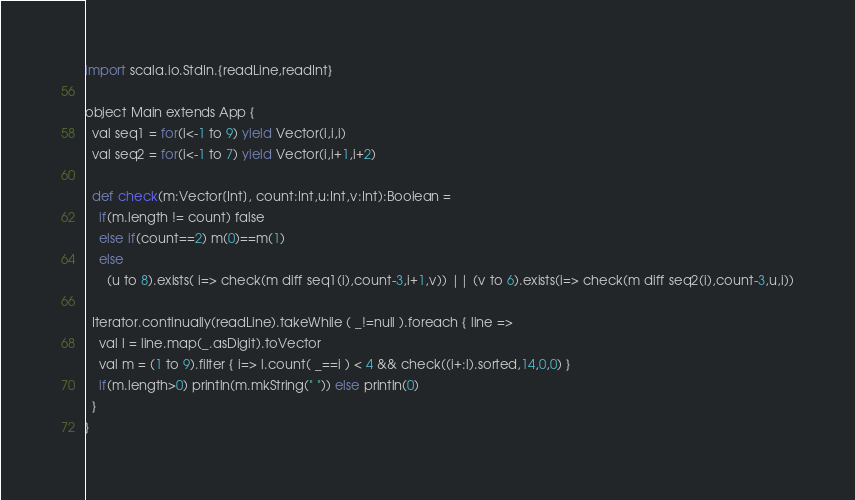Convert code to text. <code><loc_0><loc_0><loc_500><loc_500><_Python_>import scala.io.StdIn.{readLine,readInt}

object Main extends App {
  val seq1 = for(i<-1 to 9) yield Vector(i,i,i)
  val seq2 = for(i<-1 to 7) yield Vector(i,i+1,i+2)

  def check(m:Vector[Int], count:Int,u:Int,v:Int):Boolean =
    if(m.length != count) false
    else if(count==2) m(0)==m(1)
    else
      (u to 8).exists( i=> check(m diff seq1(i),count-3,i+1,v)) || (v to 6).exists(i=> check(m diff seq2(i),count-3,u,i))

  Iterator.continually(readLine).takeWhile ( _!=null ).foreach { line =>
    val l = line.map(_.asDigit).toVector
    val m = (1 to 9).filter { i=> l.count( _==i ) < 4 && check((i+:l).sorted,14,0,0) }
    if(m.length>0) println(m.mkString(" ")) else println(0)
  }
}</code> 